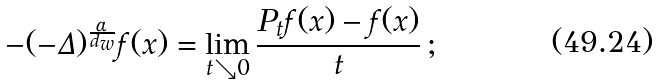<formula> <loc_0><loc_0><loc_500><loc_500>- ( - \Delta ) ^ { \frac { \alpha } { d _ { w } } } f ( x ) = \lim _ { t \searrow 0 } \frac { P _ { t } f ( x ) - f ( x ) } { t } \, ;</formula> 